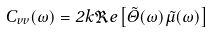<formula> <loc_0><loc_0><loc_500><loc_500>C _ { v v } ( \omega ) = 2 k \Re e \left [ \tilde { \Theta } ( \omega ) \tilde { \mu } ( \omega ) \right ]</formula> 